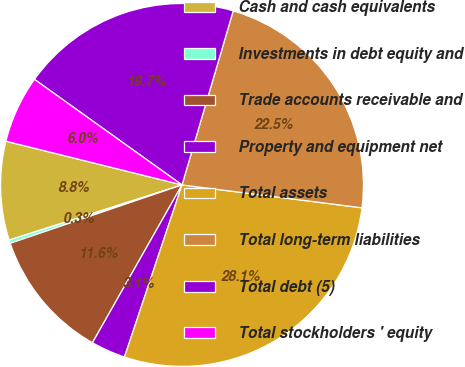Convert chart to OTSL. <chart><loc_0><loc_0><loc_500><loc_500><pie_chart><fcel>Cash and cash equivalents<fcel>Investments in debt equity and<fcel>Trade accounts receivable and<fcel>Property and equipment net<fcel>Total assets<fcel>Total long-term liabilities<fcel>Total debt (5)<fcel>Total stockholders ' equity<nl><fcel>8.79%<fcel>0.3%<fcel>11.57%<fcel>3.08%<fcel>28.12%<fcel>22.46%<fcel>19.67%<fcel>6.01%<nl></chart> 